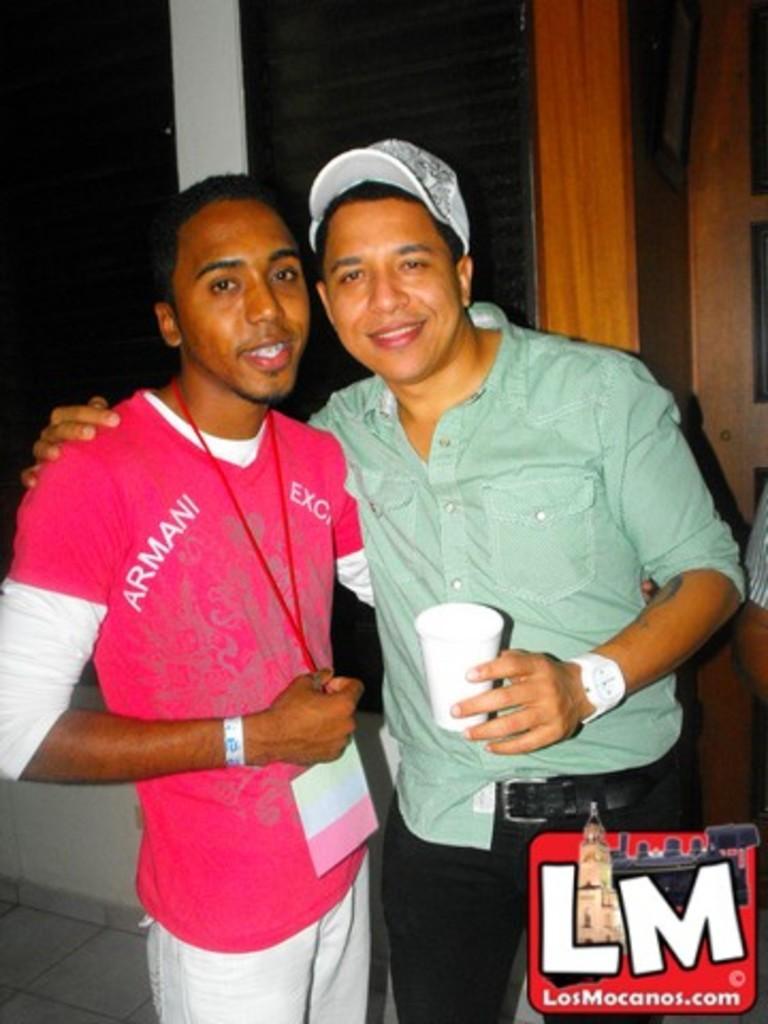In one or two sentences, can you explain what this image depicts? In the picture I can see a man holding a glass in the hand and the man on the left side is holding an ID card. Here I can see a logo on the image. In the background I can see a wall. 